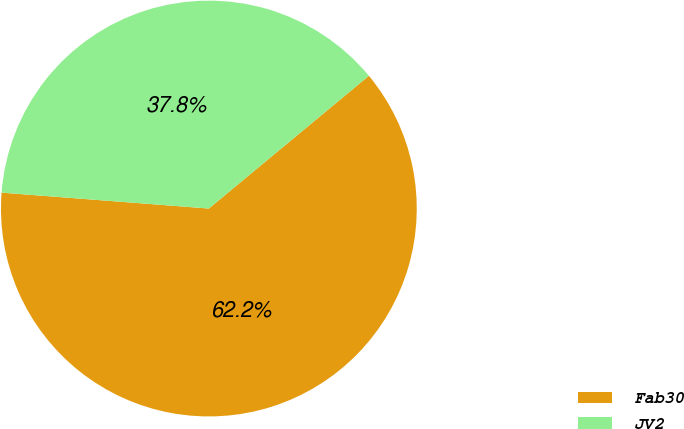Convert chart to OTSL. <chart><loc_0><loc_0><loc_500><loc_500><pie_chart><fcel>Fab30<fcel>JV2<nl><fcel>62.24%<fcel>37.76%<nl></chart> 